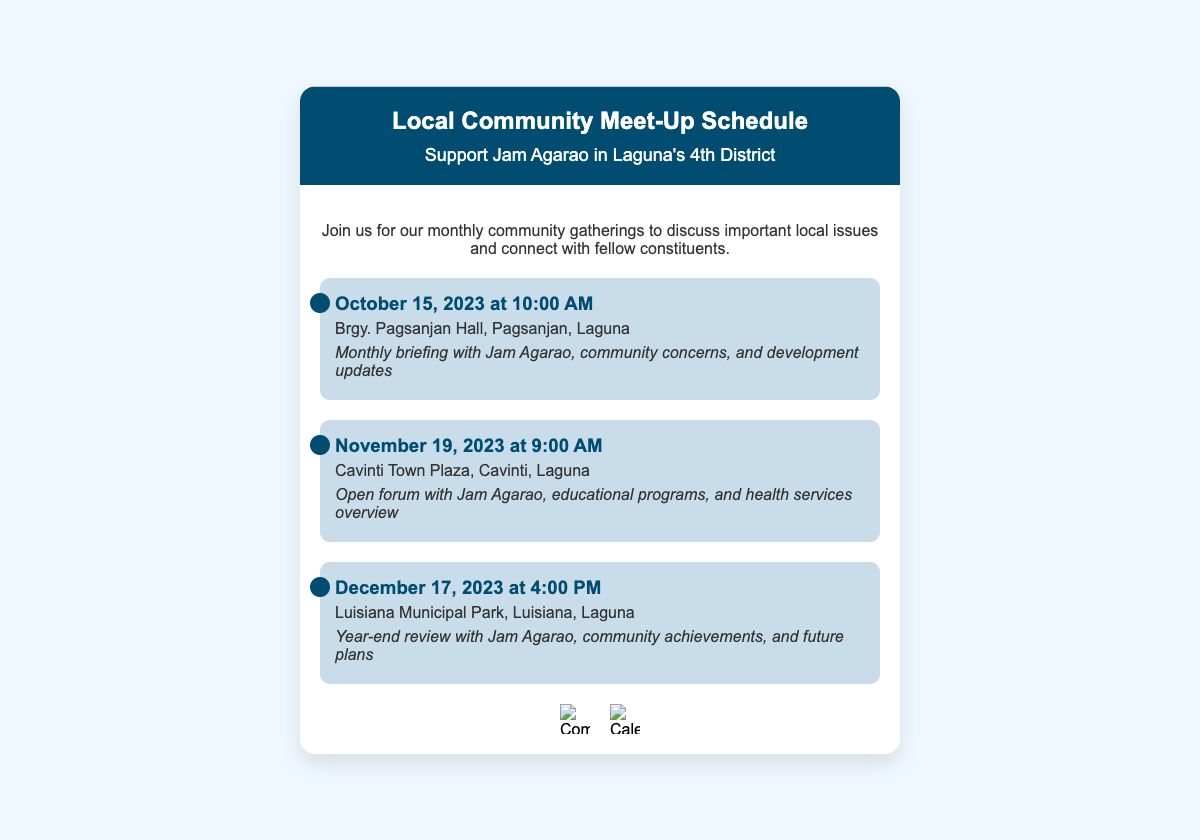What is the title of the document? The title of the document is mentioned at the top within the header section.
Answer: Local Community Meet-Up Schedule When is the next meeting after October? The next meeting mentioned is after October, on November 19, 2023.
Answer: November 19, 2023 Where is the December meeting located? The location of the December meeting is specified in the meeting details.
Answer: Luisiana Municipal Park, Luisiana, Laguna What time is the October meeting scheduled for? The time for the October meeting is given in the meeting details.
Answer: 10:00 AM What type of event is scheduled for November? The type of event for November is indicated as an open forum.
Answer: Open forum How many meetings are listed in total? The total number of meetings can be counted from the document's meetings section.
Answer: Three What color is used for the header background? The background color of the header is defined in the style section.
Answer: Dark blue (#004d71) What is the focus of the December meeting? The focus of the December meeting is summarized in the highlights of that meeting.
Answer: Year-end review Who is hosting the community meet-ups? The host of the community meet-ups is specified in each meeting's description.
Answer: Jam Agarao 